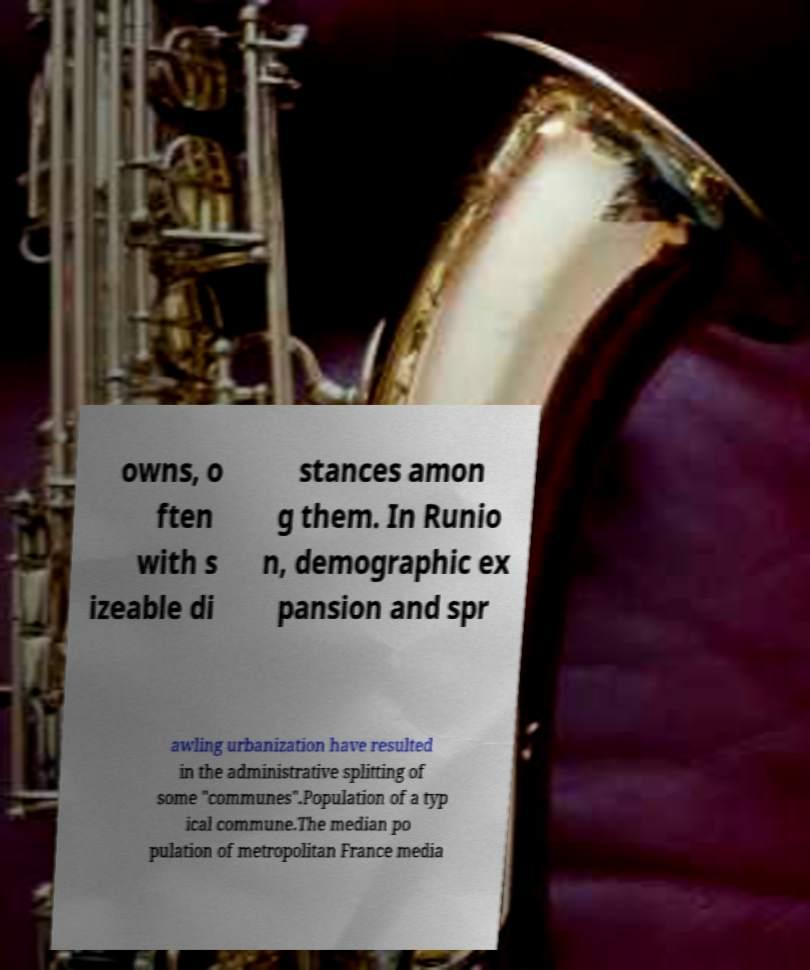I need the written content from this picture converted into text. Can you do that? owns, o ften with s izeable di stances amon g them. In Runio n, demographic ex pansion and spr awling urbanization have resulted in the administrative splitting of some "communes".Population of a typ ical commune.The median po pulation of metropolitan France media 